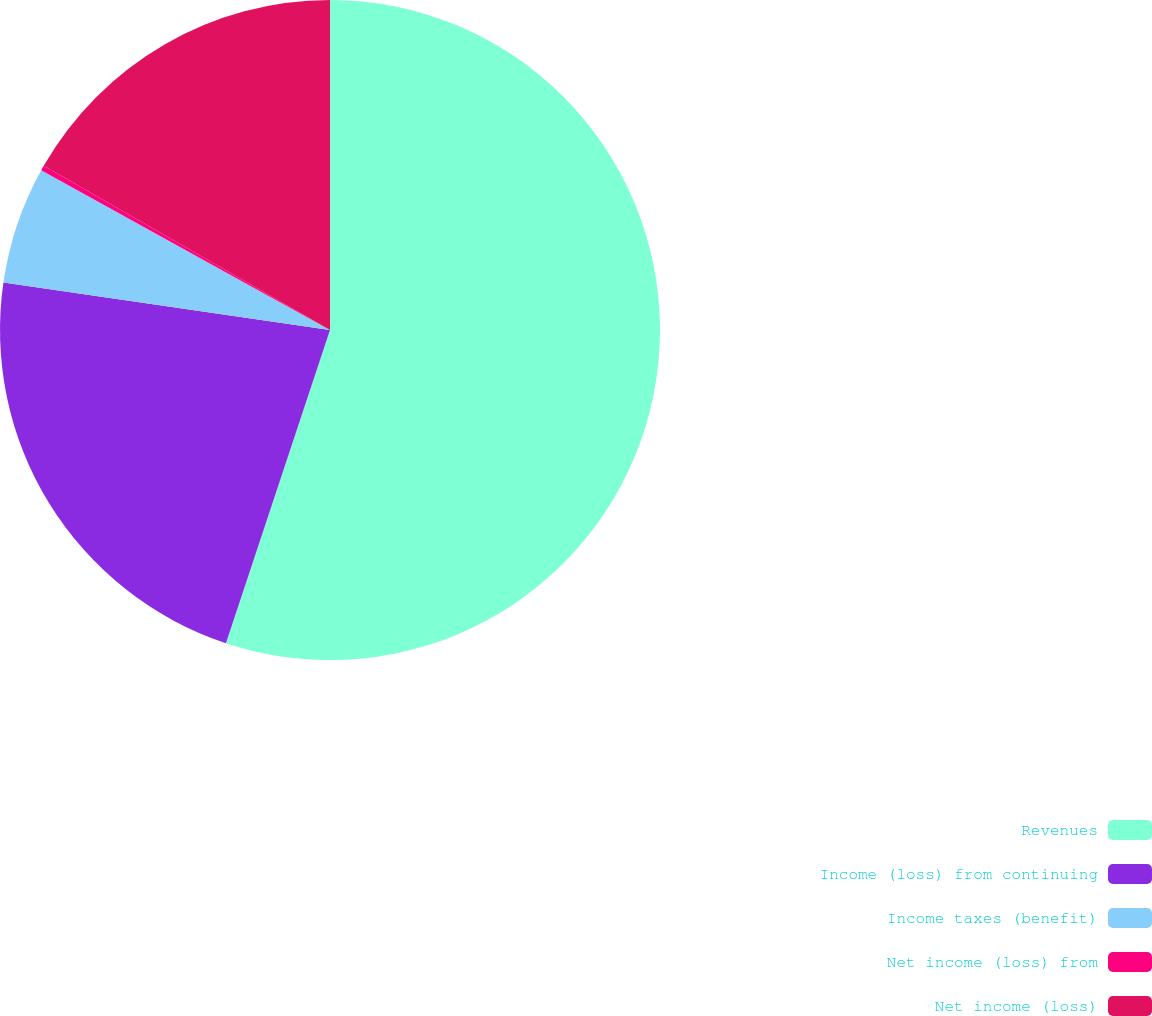<chart> <loc_0><loc_0><loc_500><loc_500><pie_chart><fcel>Revenues<fcel>Income (loss) from continuing<fcel>Income taxes (benefit)<fcel>Net income (loss) from<fcel>Net income (loss)<nl><fcel>55.1%<fcel>22.19%<fcel>5.74%<fcel>0.25%<fcel>16.71%<nl></chart> 